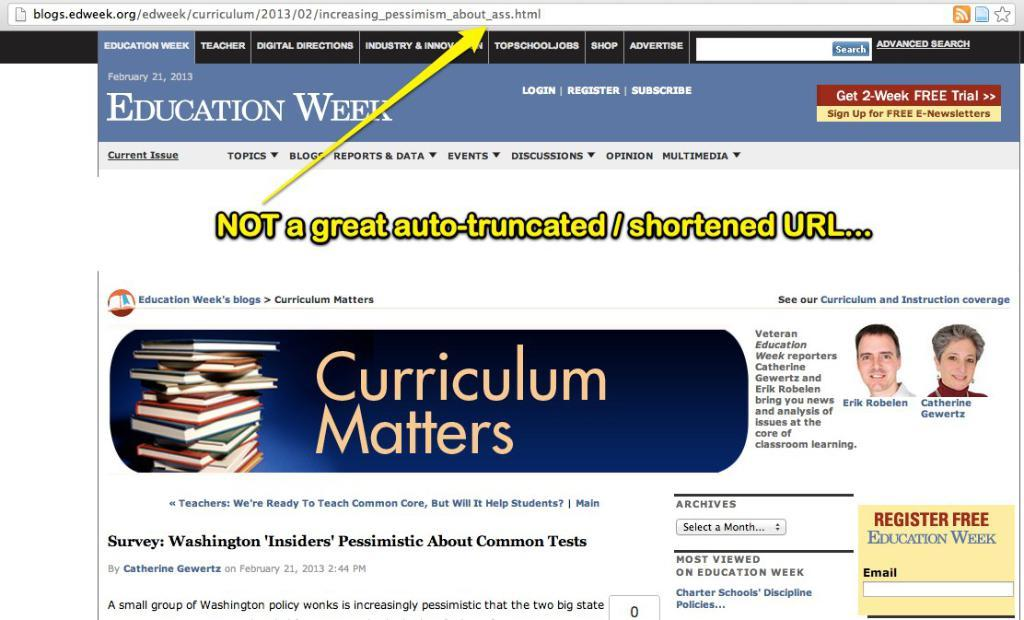Provide a one-sentence caption for the provided image. A website for Education Week displays a banner for Curriculum Matters. 